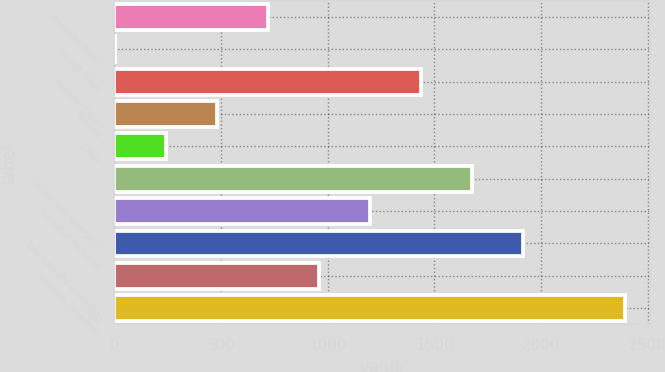Convert chart to OTSL. <chart><loc_0><loc_0><loc_500><loc_500><bar_chart><fcel>Anadarko Basin<fcel>Barnett Shale<fcel>Permian Basin<fcel>Rockies<fcel>Other<fcel>US core and emerging<fcel>Canadian heavy oil<fcel>Total core and emerging<fcel>Non-core properties<fcel>Total<nl><fcel>719.42<fcel>2<fcel>1436.84<fcel>480.28<fcel>241.14<fcel>1675.98<fcel>1197.7<fcel>1915.12<fcel>958.56<fcel>2393.4<nl></chart> 